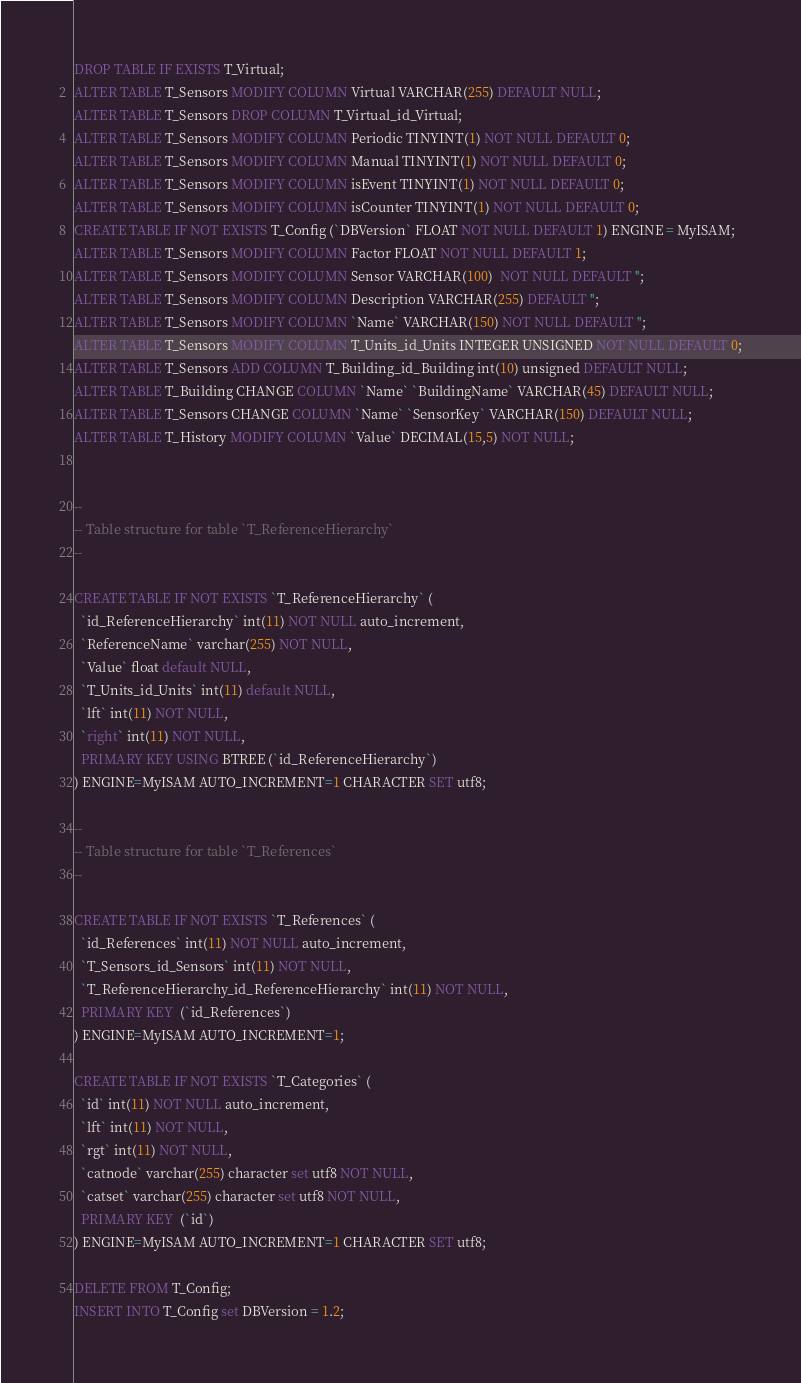<code> <loc_0><loc_0><loc_500><loc_500><_SQL_>DROP TABLE IF EXISTS T_Virtual;
ALTER TABLE T_Sensors MODIFY COLUMN Virtual VARCHAR(255) DEFAULT NULL;
ALTER TABLE T_Sensors DROP COLUMN T_Virtual_id_Virtual;
ALTER TABLE T_Sensors MODIFY COLUMN Periodic TINYINT(1) NOT NULL DEFAULT 0;
ALTER TABLE T_Sensors MODIFY COLUMN Manual TINYINT(1) NOT NULL DEFAULT 0;
ALTER TABLE T_Sensors MODIFY COLUMN isEvent TINYINT(1) NOT NULL DEFAULT 0;
ALTER TABLE T_Sensors MODIFY COLUMN isCounter TINYINT(1) NOT NULL DEFAULT 0;
CREATE TABLE IF NOT EXISTS T_Config (`DBVersion` FLOAT NOT NULL DEFAULT 1) ENGINE = MyISAM;
ALTER TABLE T_Sensors MODIFY COLUMN Factor FLOAT NOT NULL DEFAULT 1;
ALTER TABLE T_Sensors MODIFY COLUMN Sensor VARCHAR(100)  NOT NULL DEFAULT '';
ALTER TABLE T_Sensors MODIFY COLUMN Description VARCHAR(255) DEFAULT '';
ALTER TABLE T_Sensors MODIFY COLUMN `Name` VARCHAR(150) NOT NULL DEFAULT '';
ALTER TABLE T_Sensors MODIFY COLUMN T_Units_id_Units INTEGER UNSIGNED NOT NULL DEFAULT 0;
ALTER TABLE T_Sensors ADD COLUMN T_Building_id_Building int(10) unsigned DEFAULT NULL;
ALTER TABLE T_Building CHANGE COLUMN `Name` `BuildingName` VARCHAR(45) DEFAULT NULL;
ALTER TABLE T_Sensors CHANGE COLUMN `Name` `SensorKey` VARCHAR(150) DEFAULT NULL;
ALTER TABLE T_History MODIFY COLUMN `Value` DECIMAL(15,5) NOT NULL;


--
-- Table structure for table `T_ReferenceHierarchy`
--

CREATE TABLE IF NOT EXISTS `T_ReferenceHierarchy` (
  `id_ReferenceHierarchy` int(11) NOT NULL auto_increment,
  `ReferenceName` varchar(255) NOT NULL,
  `Value` float default NULL,
  `T_Units_id_Units` int(11) default NULL,
  `lft` int(11) NOT NULL,
  `right` int(11) NOT NULL,
  PRIMARY KEY USING BTREE (`id_ReferenceHierarchy`)
) ENGINE=MyISAM AUTO_INCREMENT=1 CHARACTER SET utf8;

--
-- Table structure for table `T_References`
--

CREATE TABLE IF NOT EXISTS `T_References` (
  `id_References` int(11) NOT NULL auto_increment,
  `T_Sensors_id_Sensors` int(11) NOT NULL,
  `T_ReferenceHierarchy_id_ReferenceHierarchy` int(11) NOT NULL,
  PRIMARY KEY  (`id_References`)
) ENGINE=MyISAM AUTO_INCREMENT=1;

CREATE TABLE IF NOT EXISTS `T_Categories` (
  `id` int(11) NOT NULL auto_increment,
  `lft` int(11) NOT NULL,
  `rgt` int(11) NOT NULL,
  `catnode` varchar(255) character set utf8 NOT NULL,
  `catset` varchar(255) character set utf8 NOT NULL,
  PRIMARY KEY  (`id`)
) ENGINE=MyISAM AUTO_INCREMENT=1 CHARACTER SET utf8;

DELETE FROM T_Config;
INSERT INTO T_Config set DBVersion = 1.2;</code> 